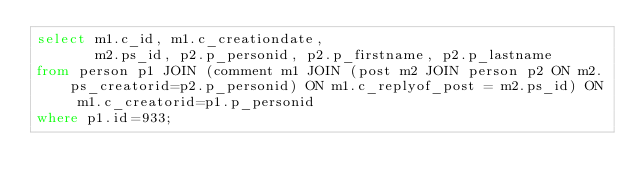Convert code to text. <code><loc_0><loc_0><loc_500><loc_500><_SQL_>select m1.c_id, m1.c_creationdate,
       m2.ps_id, p2.p_personid, p2.p_firstname, p2.p_lastname
from person p1 JOIN (comment m1 JOIN (post m2 JOIN person p2 ON m2.ps_creatorid=p2.p_personid) ON m1.c_replyof_post = m2.ps_id) ON m1.c_creatorid=p1.p_personid 
where p1.id=933;
</code> 